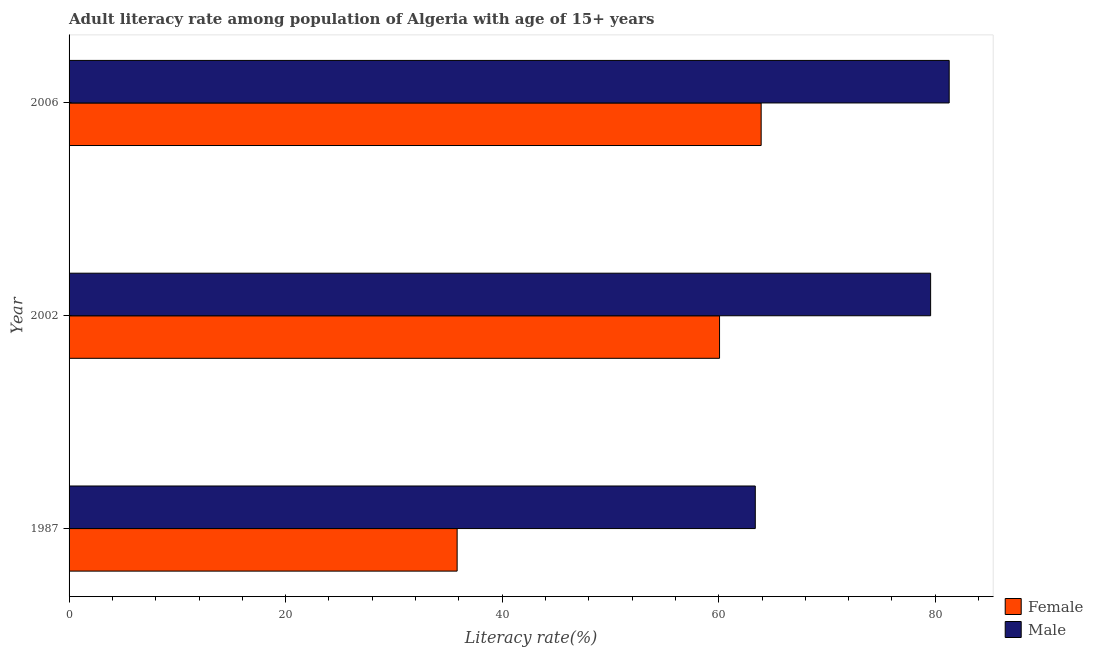How many different coloured bars are there?
Provide a succinct answer. 2. Are the number of bars on each tick of the Y-axis equal?
Offer a very short reply. Yes. In how many cases, is the number of bars for a given year not equal to the number of legend labels?
Provide a short and direct response. 0. What is the male adult literacy rate in 2002?
Your answer should be very brief. 79.57. Across all years, what is the maximum male adult literacy rate?
Make the answer very short. 81.28. Across all years, what is the minimum female adult literacy rate?
Make the answer very short. 35.84. In which year was the male adult literacy rate maximum?
Your response must be concise. 2006. In which year was the male adult literacy rate minimum?
Make the answer very short. 1987. What is the total male adult literacy rate in the graph?
Offer a very short reply. 224.23. What is the difference between the female adult literacy rate in 1987 and that in 2006?
Your answer should be compact. -28.08. What is the difference between the male adult literacy rate in 2006 and the female adult literacy rate in 1987?
Keep it short and to the point. 45.44. What is the average female adult literacy rate per year?
Offer a terse response. 53.28. In the year 1987, what is the difference between the male adult literacy rate and female adult literacy rate?
Offer a terse response. 27.54. What is the ratio of the male adult literacy rate in 1987 to that in 2006?
Give a very brief answer. 0.78. Is the difference between the female adult literacy rate in 1987 and 2002 greater than the difference between the male adult literacy rate in 1987 and 2002?
Keep it short and to the point. No. What is the difference between the highest and the second highest male adult literacy rate?
Ensure brevity in your answer.  1.72. What is the difference between the highest and the lowest female adult literacy rate?
Your response must be concise. 28.08. Is the sum of the female adult literacy rate in 1987 and 2002 greater than the maximum male adult literacy rate across all years?
Offer a very short reply. Yes. What does the 2nd bar from the top in 2006 represents?
Ensure brevity in your answer.  Female. What does the 2nd bar from the bottom in 1987 represents?
Your answer should be compact. Male. How many bars are there?
Ensure brevity in your answer.  6. Are all the bars in the graph horizontal?
Your response must be concise. Yes. Does the graph contain any zero values?
Offer a terse response. No. Where does the legend appear in the graph?
Offer a terse response. Bottom right. How are the legend labels stacked?
Your response must be concise. Vertical. What is the title of the graph?
Provide a short and direct response. Adult literacy rate among population of Algeria with age of 15+ years. What is the label or title of the X-axis?
Make the answer very short. Literacy rate(%). What is the Literacy rate(%) in Female in 1987?
Offer a very short reply. 35.84. What is the Literacy rate(%) of Male in 1987?
Your answer should be very brief. 63.38. What is the Literacy rate(%) of Female in 2002?
Make the answer very short. 60.08. What is the Literacy rate(%) in Male in 2002?
Offer a terse response. 79.57. What is the Literacy rate(%) in Female in 2006?
Ensure brevity in your answer.  63.92. What is the Literacy rate(%) of Male in 2006?
Provide a succinct answer. 81.28. Across all years, what is the maximum Literacy rate(%) of Female?
Offer a terse response. 63.92. Across all years, what is the maximum Literacy rate(%) in Male?
Offer a terse response. 81.28. Across all years, what is the minimum Literacy rate(%) of Female?
Provide a succinct answer. 35.84. Across all years, what is the minimum Literacy rate(%) in Male?
Offer a terse response. 63.38. What is the total Literacy rate(%) of Female in the graph?
Provide a short and direct response. 159.83. What is the total Literacy rate(%) in Male in the graph?
Your answer should be very brief. 224.23. What is the difference between the Literacy rate(%) in Female in 1987 and that in 2002?
Offer a very short reply. -24.24. What is the difference between the Literacy rate(%) in Male in 1987 and that in 2002?
Give a very brief answer. -16.19. What is the difference between the Literacy rate(%) of Female in 1987 and that in 2006?
Give a very brief answer. -28.08. What is the difference between the Literacy rate(%) of Male in 1987 and that in 2006?
Your response must be concise. -17.91. What is the difference between the Literacy rate(%) in Female in 2002 and that in 2006?
Ensure brevity in your answer.  -3.84. What is the difference between the Literacy rate(%) of Male in 2002 and that in 2006?
Offer a terse response. -1.72. What is the difference between the Literacy rate(%) in Female in 1987 and the Literacy rate(%) in Male in 2002?
Offer a terse response. -43.73. What is the difference between the Literacy rate(%) in Female in 1987 and the Literacy rate(%) in Male in 2006?
Your answer should be very brief. -45.44. What is the difference between the Literacy rate(%) in Female in 2002 and the Literacy rate(%) in Male in 2006?
Make the answer very short. -21.21. What is the average Literacy rate(%) in Female per year?
Give a very brief answer. 53.28. What is the average Literacy rate(%) of Male per year?
Keep it short and to the point. 74.74. In the year 1987, what is the difference between the Literacy rate(%) in Female and Literacy rate(%) in Male?
Your answer should be compact. -27.54. In the year 2002, what is the difference between the Literacy rate(%) in Female and Literacy rate(%) in Male?
Make the answer very short. -19.49. In the year 2006, what is the difference between the Literacy rate(%) in Female and Literacy rate(%) in Male?
Your answer should be very brief. -17.37. What is the ratio of the Literacy rate(%) of Female in 1987 to that in 2002?
Offer a terse response. 0.6. What is the ratio of the Literacy rate(%) of Male in 1987 to that in 2002?
Your response must be concise. 0.8. What is the ratio of the Literacy rate(%) in Female in 1987 to that in 2006?
Provide a short and direct response. 0.56. What is the ratio of the Literacy rate(%) in Male in 1987 to that in 2006?
Provide a succinct answer. 0.78. What is the ratio of the Literacy rate(%) of Female in 2002 to that in 2006?
Offer a terse response. 0.94. What is the ratio of the Literacy rate(%) of Male in 2002 to that in 2006?
Provide a short and direct response. 0.98. What is the difference between the highest and the second highest Literacy rate(%) in Female?
Your answer should be compact. 3.84. What is the difference between the highest and the second highest Literacy rate(%) in Male?
Your response must be concise. 1.72. What is the difference between the highest and the lowest Literacy rate(%) in Female?
Offer a very short reply. 28.08. What is the difference between the highest and the lowest Literacy rate(%) in Male?
Ensure brevity in your answer.  17.91. 